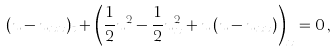<formula> <loc_0><loc_0><loc_500><loc_500>( u - u _ { x x } ) _ { t } + \left ( \frac { 1 } { 2 } u ^ { 2 } - \frac { 1 } { 2 } u _ { x } ^ { 2 } + u \, ( u - u _ { x x } ) \right ) _ { x } = 0 \, ,</formula> 